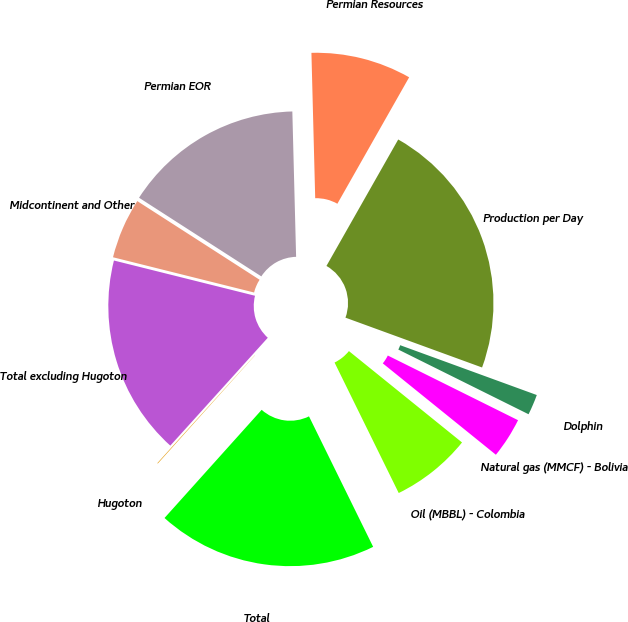Convert chart. <chart><loc_0><loc_0><loc_500><loc_500><pie_chart><fcel>Production per Day<fcel>Permian Resources<fcel>Permian EOR<fcel>Midcontinent and Other<fcel>Total excluding Hugoton<fcel>Hugoton<fcel>Total<fcel>Oil (MBBL) - Colombia<fcel>Natural gas (MMCF) - Bolivia<fcel>Dolphin<nl><fcel>22.35%<fcel>8.63%<fcel>15.49%<fcel>5.2%<fcel>17.2%<fcel>0.05%<fcel>18.92%<fcel>6.91%<fcel>3.48%<fcel>1.77%<nl></chart> 